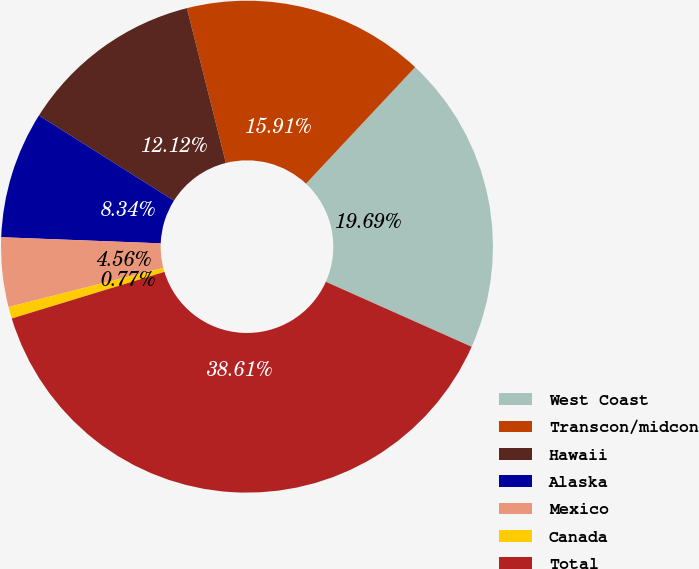Convert chart to OTSL. <chart><loc_0><loc_0><loc_500><loc_500><pie_chart><fcel>West Coast<fcel>Transcon/midcon<fcel>Hawaii<fcel>Alaska<fcel>Mexico<fcel>Canada<fcel>Total<nl><fcel>19.69%<fcel>15.91%<fcel>12.12%<fcel>8.34%<fcel>4.56%<fcel>0.77%<fcel>38.61%<nl></chart> 